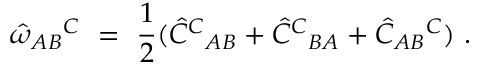Convert formula to latex. <formula><loc_0><loc_0><loc_500><loc_500>\hat { \omega } _ { A B ^ { C } \ = \ \frac { 1 } { 2 } ( \hat { C } ^ { C _ { A B } + \hat { C } ^ { C _ { B A } + \hat { C } _ { A B ^ { C } ) .</formula> 